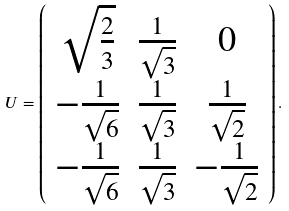Convert formula to latex. <formula><loc_0><loc_0><loc_500><loc_500>U = \left ( \begin{array} { c c c } \sqrt { \frac { 2 } { 3 } } & \frac { 1 } { \sqrt { 3 } } & 0 \\ - \frac { 1 } { \sqrt { 6 } } & \frac { 1 } { \sqrt { 3 } } & \frac { 1 } { \sqrt { 2 } } \\ - \frac { 1 } { \sqrt { 6 } } & \frac { 1 } { \sqrt { 3 } } & - \frac { 1 } { \sqrt { 2 } } \end{array} \right ) .</formula> 